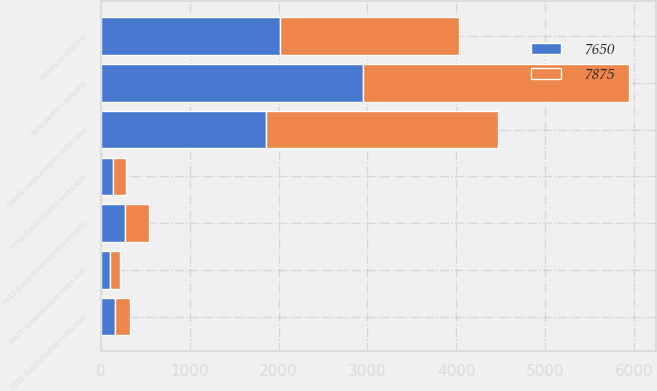Convert chart to OTSL. <chart><loc_0><loc_0><loc_500><loc_500><stacked_bar_chart><ecel><fcel>dollars in millions<fcel>Senior medium-term notes due<fcel>0975 Subordinated notes due<fcel>6875 Subordinated notes due<fcel>7750 Subordinated notes due<fcel>Total parent company<fcel>7413 Subordinated remarketable<nl><fcel>7875<fcel>2014<fcel>2611<fcel>162<fcel>113<fcel>147<fcel>2997<fcel>272<nl><fcel>7650<fcel>2013<fcel>1858<fcel>162<fcel>103<fcel>133<fcel>2951<fcel>270<nl></chart> 